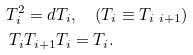<formula> <loc_0><loc_0><loc_500><loc_500>T _ { i } ^ { 2 } = d T _ { i } & , \quad ( T _ { i } \equiv T _ { i \ i + 1 } ) \\ T _ { i } T _ { i + 1 } T _ { i } & = T _ { i } .</formula> 